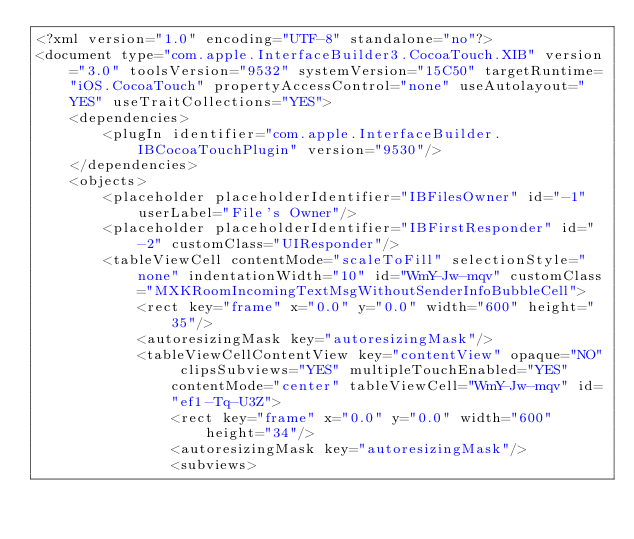Convert code to text. <code><loc_0><loc_0><loc_500><loc_500><_XML_><?xml version="1.0" encoding="UTF-8" standalone="no"?>
<document type="com.apple.InterfaceBuilder3.CocoaTouch.XIB" version="3.0" toolsVersion="9532" systemVersion="15C50" targetRuntime="iOS.CocoaTouch" propertyAccessControl="none" useAutolayout="YES" useTraitCollections="YES">
    <dependencies>
        <plugIn identifier="com.apple.InterfaceBuilder.IBCocoaTouchPlugin" version="9530"/>
    </dependencies>
    <objects>
        <placeholder placeholderIdentifier="IBFilesOwner" id="-1" userLabel="File's Owner"/>
        <placeholder placeholderIdentifier="IBFirstResponder" id="-2" customClass="UIResponder"/>
        <tableViewCell contentMode="scaleToFill" selectionStyle="none" indentationWidth="10" id="WmY-Jw-mqv" customClass="MXKRoomIncomingTextMsgWithoutSenderInfoBubbleCell">
            <rect key="frame" x="0.0" y="0.0" width="600" height="35"/>
            <autoresizingMask key="autoresizingMask"/>
            <tableViewCellContentView key="contentView" opaque="NO" clipsSubviews="YES" multipleTouchEnabled="YES" contentMode="center" tableViewCell="WmY-Jw-mqv" id="ef1-Tq-U3Z">
                <rect key="frame" x="0.0" y="0.0" width="600" height="34"/>
                <autoresizingMask key="autoresizingMask"/>
                <subviews></code> 